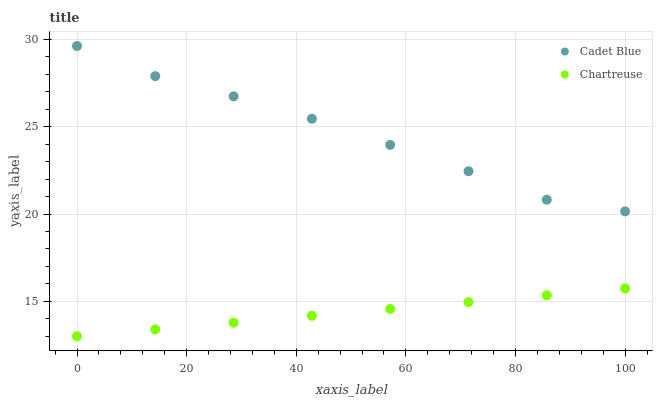Does Chartreuse have the minimum area under the curve?
Answer yes or no. Yes. Does Cadet Blue have the maximum area under the curve?
Answer yes or no. Yes. Does Cadet Blue have the minimum area under the curve?
Answer yes or no. No. Is Chartreuse the smoothest?
Answer yes or no. Yes. Is Cadet Blue the roughest?
Answer yes or no. Yes. Is Cadet Blue the smoothest?
Answer yes or no. No. Does Chartreuse have the lowest value?
Answer yes or no. Yes. Does Cadet Blue have the lowest value?
Answer yes or no. No. Does Cadet Blue have the highest value?
Answer yes or no. Yes. Is Chartreuse less than Cadet Blue?
Answer yes or no. Yes. Is Cadet Blue greater than Chartreuse?
Answer yes or no. Yes. Does Chartreuse intersect Cadet Blue?
Answer yes or no. No. 